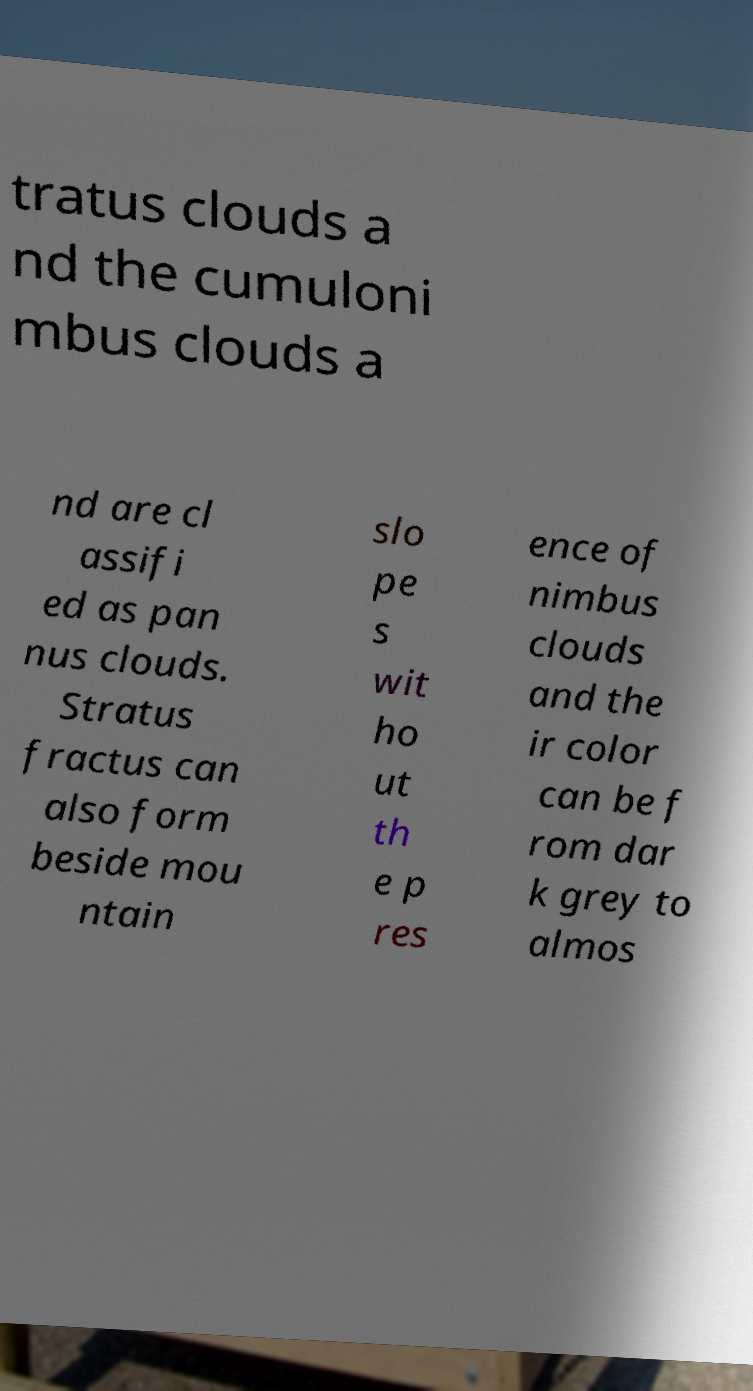What messages or text are displayed in this image? I need them in a readable, typed format. tratus clouds a nd the cumuloni mbus clouds a nd are cl assifi ed as pan nus clouds. Stratus fractus can also form beside mou ntain slo pe s wit ho ut th e p res ence of nimbus clouds and the ir color can be f rom dar k grey to almos 